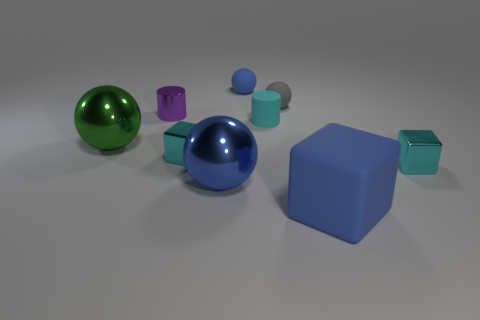What is the material of the big blue object that is the same shape as the small blue matte thing?
Make the answer very short. Metal. What shape is the large blue object that is made of the same material as the green sphere?
Keep it short and to the point. Sphere. What is the tiny cylinder behind the cyan rubber thing made of?
Make the answer very short. Metal. There is a small object right of the large matte block; does it have the same color as the matte cylinder?
Give a very brief answer. Yes. There is a cyan cube behind the cyan cube right of the blue matte sphere; what is its size?
Your answer should be compact. Small. Is the number of cyan blocks that are right of the gray rubber object greater than the number of large blue shiny blocks?
Keep it short and to the point. Yes. Is the size of the cyan metal object on the left side of the blue shiny ball the same as the small cyan rubber object?
Provide a succinct answer. Yes. There is a block that is both on the right side of the big blue metal object and behind the big cube; what is its color?
Your answer should be very brief. Cyan. There is a blue matte object that is the same size as the purple metallic object; what shape is it?
Offer a terse response. Sphere. Is there a tiny matte object of the same color as the large rubber block?
Keep it short and to the point. Yes. 